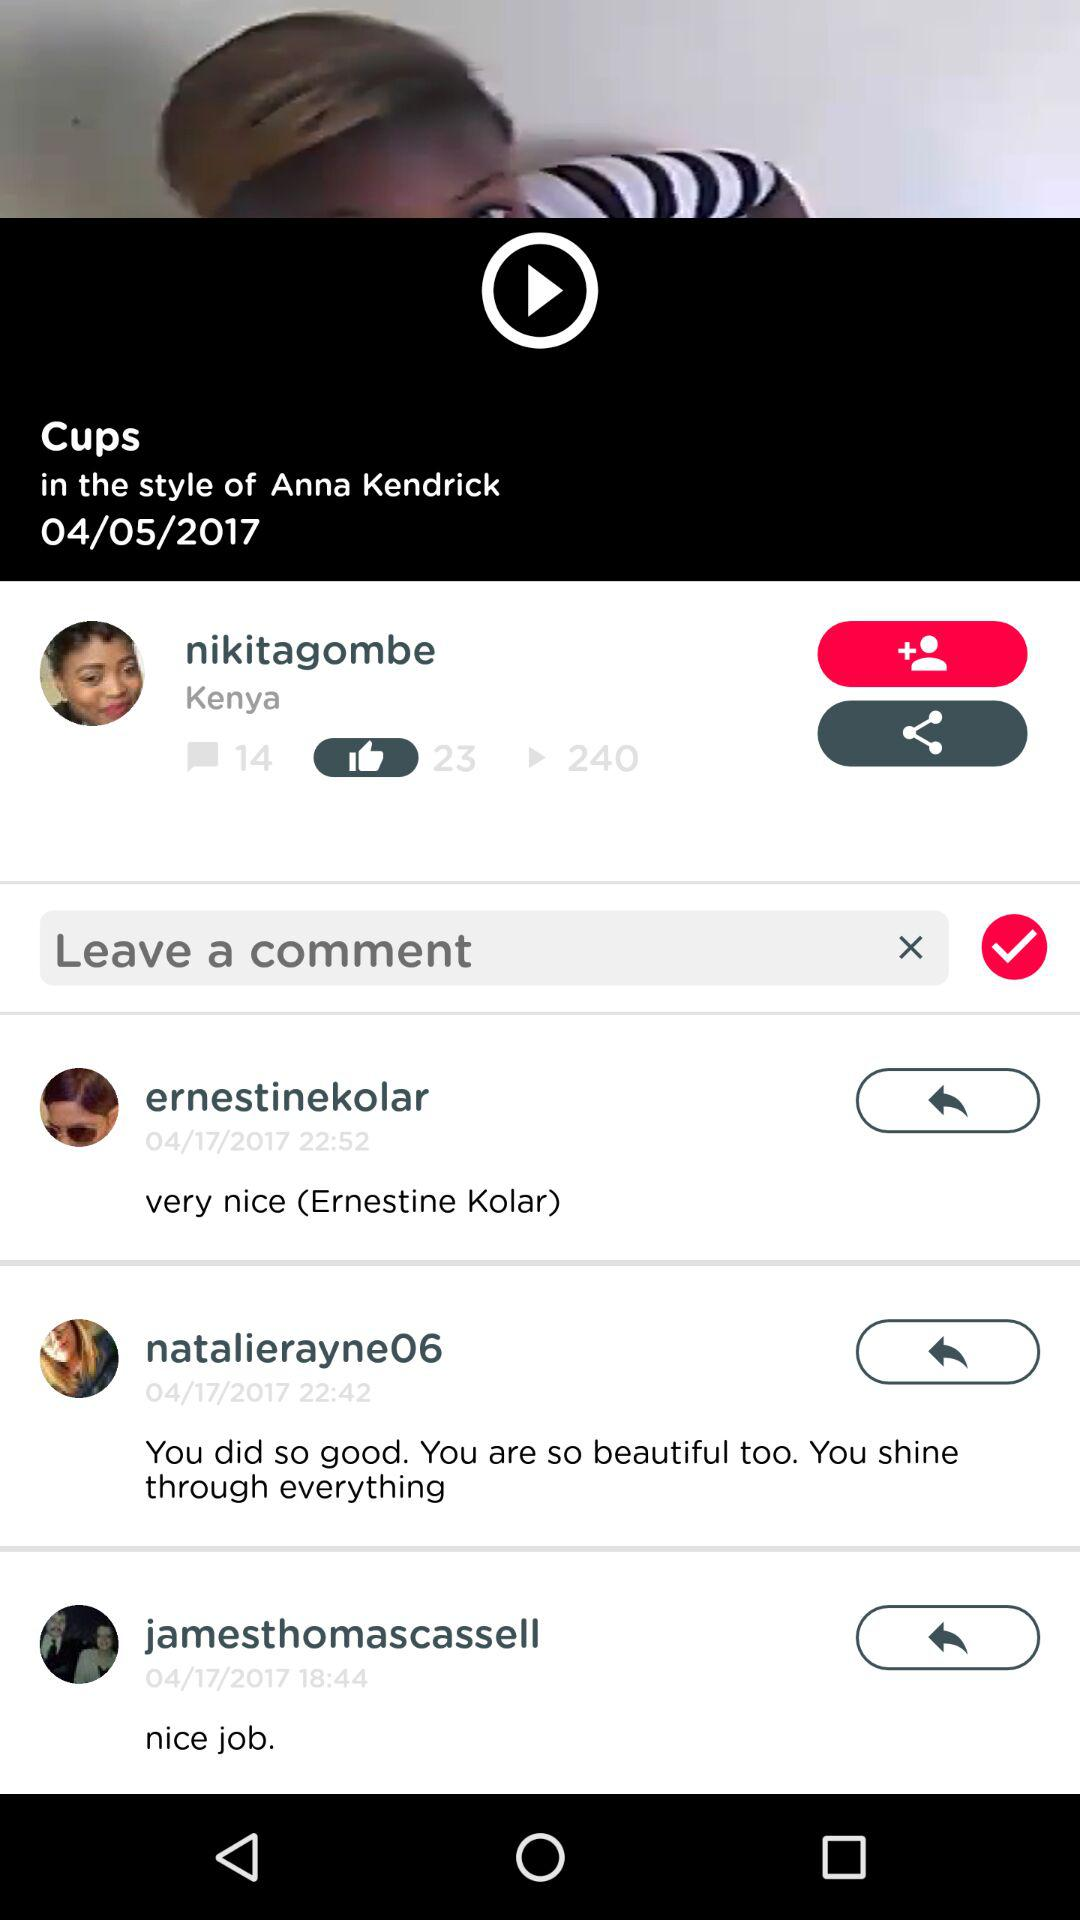How many of the comments were made by people from Kenya?
Answer the question using a single word or phrase. 1 